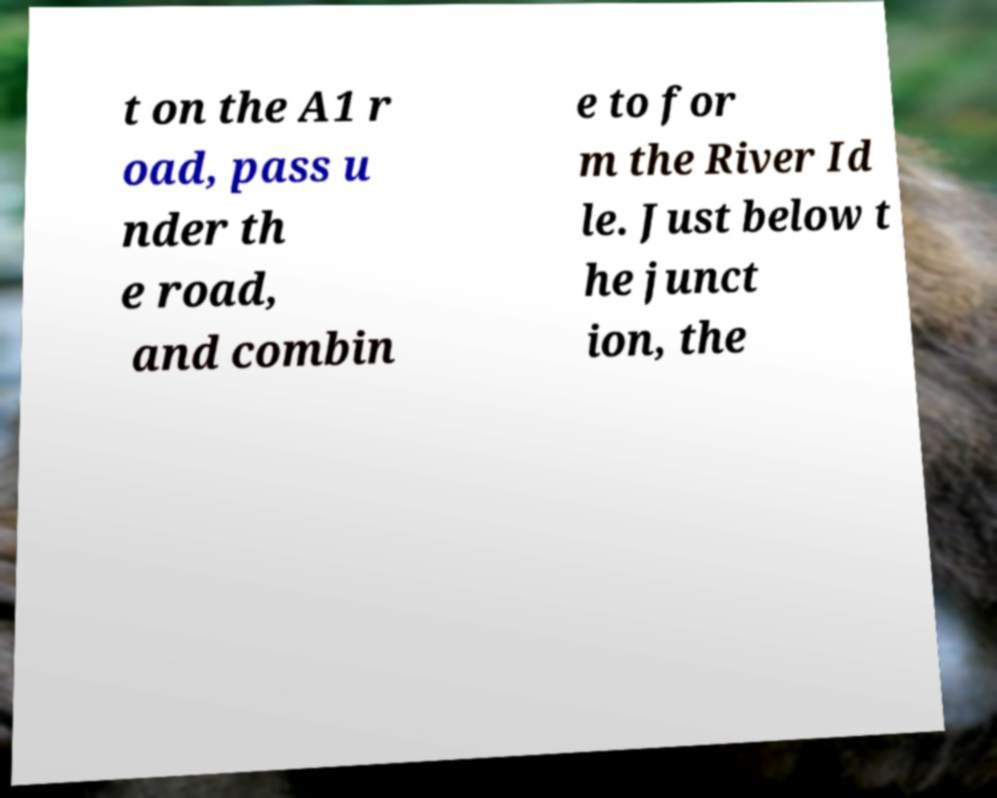Please read and relay the text visible in this image. What does it say? t on the A1 r oad, pass u nder th e road, and combin e to for m the River Id le. Just below t he junct ion, the 